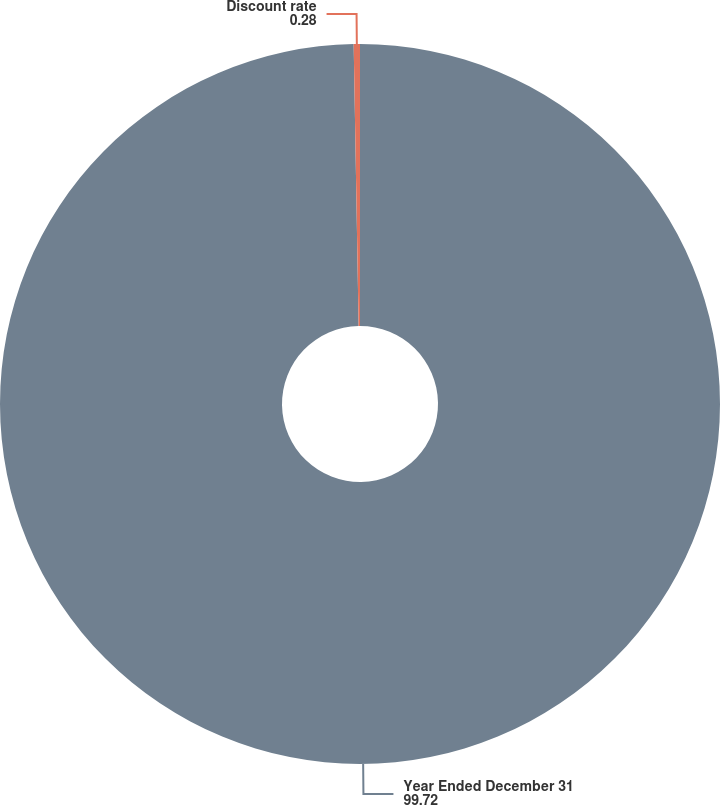<chart> <loc_0><loc_0><loc_500><loc_500><pie_chart><fcel>Year Ended December 31<fcel>Discount rate<nl><fcel>99.72%<fcel>0.28%<nl></chart> 